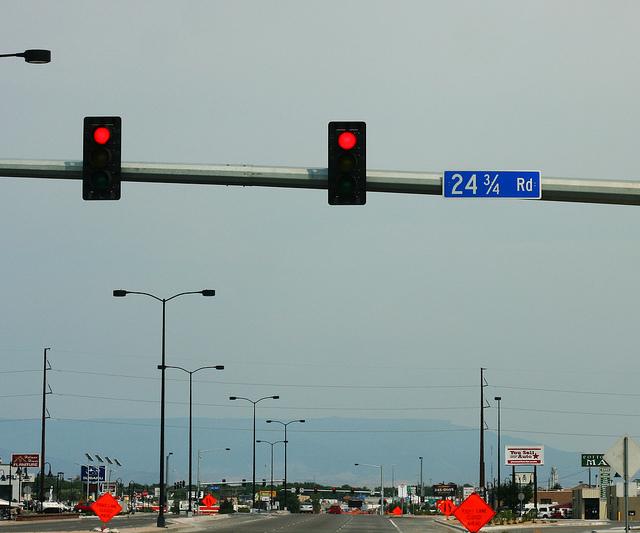How many orange signs are on the street?
Be succinct. 5. What color is the light?
Concise answer only. Red. Are the stop lights red?
Give a very brief answer. Yes. Does your vehicle have to halt here?
Keep it brief. Yes. 